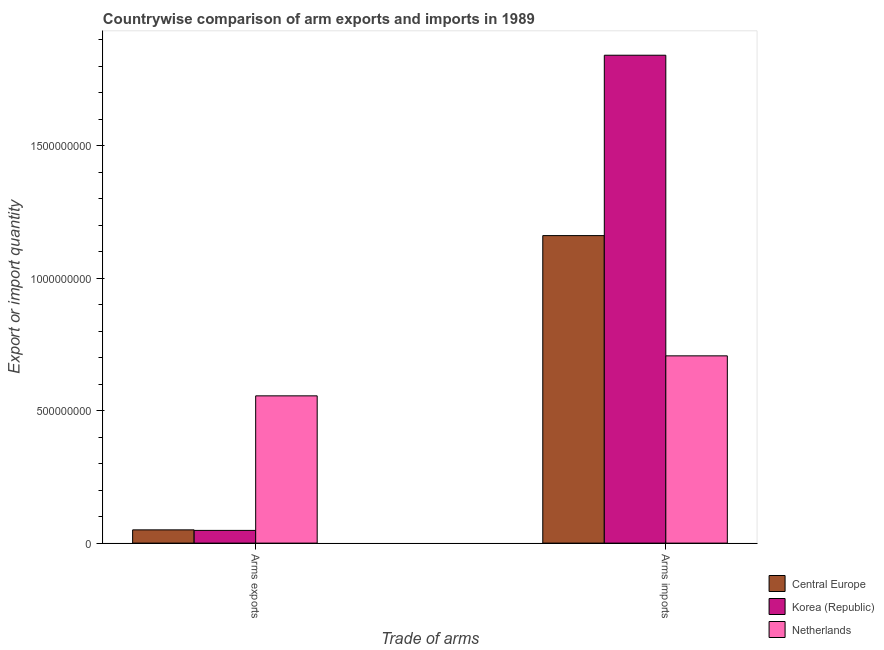How many different coloured bars are there?
Your answer should be compact. 3. How many groups of bars are there?
Provide a short and direct response. 2. Are the number of bars on each tick of the X-axis equal?
Make the answer very short. Yes. How many bars are there on the 1st tick from the right?
Give a very brief answer. 3. What is the label of the 1st group of bars from the left?
Give a very brief answer. Arms exports. What is the arms exports in Central Europe?
Provide a short and direct response. 5.00e+07. Across all countries, what is the maximum arms imports?
Your answer should be very brief. 1.84e+09. Across all countries, what is the minimum arms imports?
Offer a terse response. 7.07e+08. What is the total arms imports in the graph?
Your answer should be very brief. 3.71e+09. What is the difference between the arms imports in Korea (Republic) and that in Central Europe?
Keep it short and to the point. 6.81e+08. What is the difference between the arms imports in Korea (Republic) and the arms exports in Central Europe?
Offer a terse response. 1.79e+09. What is the average arms imports per country?
Your answer should be very brief. 1.24e+09. What is the difference between the arms exports and arms imports in Netherlands?
Your answer should be compact. -1.51e+08. In how many countries, is the arms imports greater than 1300000000 ?
Offer a very short reply. 1. What is the ratio of the arms exports in Netherlands to that in Korea (Republic)?
Your answer should be compact. 11.58. Is the arms imports in Korea (Republic) less than that in Central Europe?
Your response must be concise. No. In how many countries, is the arms imports greater than the average arms imports taken over all countries?
Your answer should be very brief. 1. What does the 1st bar from the left in Arms imports represents?
Provide a short and direct response. Central Europe. What does the 3rd bar from the right in Arms exports represents?
Make the answer very short. Central Europe. Are the values on the major ticks of Y-axis written in scientific E-notation?
Your response must be concise. No. Where does the legend appear in the graph?
Provide a short and direct response. Bottom right. How many legend labels are there?
Your response must be concise. 3. How are the legend labels stacked?
Keep it short and to the point. Vertical. What is the title of the graph?
Make the answer very short. Countrywise comparison of arm exports and imports in 1989. Does "Singapore" appear as one of the legend labels in the graph?
Ensure brevity in your answer.  No. What is the label or title of the X-axis?
Offer a terse response. Trade of arms. What is the label or title of the Y-axis?
Offer a terse response. Export or import quantity. What is the Export or import quantity in Central Europe in Arms exports?
Your answer should be very brief. 5.00e+07. What is the Export or import quantity in Korea (Republic) in Arms exports?
Give a very brief answer. 4.80e+07. What is the Export or import quantity in Netherlands in Arms exports?
Offer a very short reply. 5.56e+08. What is the Export or import quantity of Central Europe in Arms imports?
Offer a terse response. 1.16e+09. What is the Export or import quantity in Korea (Republic) in Arms imports?
Provide a short and direct response. 1.84e+09. What is the Export or import quantity in Netherlands in Arms imports?
Give a very brief answer. 7.07e+08. Across all Trade of arms, what is the maximum Export or import quantity of Central Europe?
Give a very brief answer. 1.16e+09. Across all Trade of arms, what is the maximum Export or import quantity of Korea (Republic)?
Offer a very short reply. 1.84e+09. Across all Trade of arms, what is the maximum Export or import quantity of Netherlands?
Keep it short and to the point. 7.07e+08. Across all Trade of arms, what is the minimum Export or import quantity of Korea (Republic)?
Your answer should be compact. 4.80e+07. Across all Trade of arms, what is the minimum Export or import quantity of Netherlands?
Your answer should be compact. 5.56e+08. What is the total Export or import quantity of Central Europe in the graph?
Ensure brevity in your answer.  1.21e+09. What is the total Export or import quantity of Korea (Republic) in the graph?
Your answer should be very brief. 1.89e+09. What is the total Export or import quantity of Netherlands in the graph?
Make the answer very short. 1.26e+09. What is the difference between the Export or import quantity in Central Europe in Arms exports and that in Arms imports?
Your answer should be very brief. -1.11e+09. What is the difference between the Export or import quantity of Korea (Republic) in Arms exports and that in Arms imports?
Give a very brief answer. -1.79e+09. What is the difference between the Export or import quantity in Netherlands in Arms exports and that in Arms imports?
Offer a terse response. -1.51e+08. What is the difference between the Export or import quantity in Central Europe in Arms exports and the Export or import quantity in Korea (Republic) in Arms imports?
Provide a short and direct response. -1.79e+09. What is the difference between the Export or import quantity in Central Europe in Arms exports and the Export or import quantity in Netherlands in Arms imports?
Your response must be concise. -6.57e+08. What is the difference between the Export or import quantity in Korea (Republic) in Arms exports and the Export or import quantity in Netherlands in Arms imports?
Offer a terse response. -6.59e+08. What is the average Export or import quantity of Central Europe per Trade of arms?
Make the answer very short. 6.06e+08. What is the average Export or import quantity in Korea (Republic) per Trade of arms?
Offer a terse response. 9.45e+08. What is the average Export or import quantity in Netherlands per Trade of arms?
Ensure brevity in your answer.  6.32e+08. What is the difference between the Export or import quantity of Central Europe and Export or import quantity of Korea (Republic) in Arms exports?
Keep it short and to the point. 2.00e+06. What is the difference between the Export or import quantity of Central Europe and Export or import quantity of Netherlands in Arms exports?
Offer a terse response. -5.06e+08. What is the difference between the Export or import quantity in Korea (Republic) and Export or import quantity in Netherlands in Arms exports?
Your answer should be very brief. -5.08e+08. What is the difference between the Export or import quantity in Central Europe and Export or import quantity in Korea (Republic) in Arms imports?
Your response must be concise. -6.81e+08. What is the difference between the Export or import quantity of Central Europe and Export or import quantity of Netherlands in Arms imports?
Ensure brevity in your answer.  4.54e+08. What is the difference between the Export or import quantity in Korea (Republic) and Export or import quantity in Netherlands in Arms imports?
Give a very brief answer. 1.14e+09. What is the ratio of the Export or import quantity of Central Europe in Arms exports to that in Arms imports?
Provide a short and direct response. 0.04. What is the ratio of the Export or import quantity of Korea (Republic) in Arms exports to that in Arms imports?
Ensure brevity in your answer.  0.03. What is the ratio of the Export or import quantity of Netherlands in Arms exports to that in Arms imports?
Your answer should be very brief. 0.79. What is the difference between the highest and the second highest Export or import quantity in Central Europe?
Provide a succinct answer. 1.11e+09. What is the difference between the highest and the second highest Export or import quantity of Korea (Republic)?
Ensure brevity in your answer.  1.79e+09. What is the difference between the highest and the second highest Export or import quantity of Netherlands?
Ensure brevity in your answer.  1.51e+08. What is the difference between the highest and the lowest Export or import quantity of Central Europe?
Your answer should be compact. 1.11e+09. What is the difference between the highest and the lowest Export or import quantity of Korea (Republic)?
Provide a short and direct response. 1.79e+09. What is the difference between the highest and the lowest Export or import quantity in Netherlands?
Your answer should be very brief. 1.51e+08. 